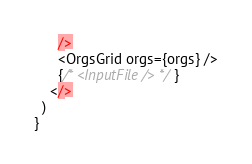<code> <loc_0><loc_0><loc_500><loc_500><_JavaScript_>      />
      <OrgsGrid orgs={orgs} />
      {/* <InputFile /> */}
    </>
  )
}
</code> 